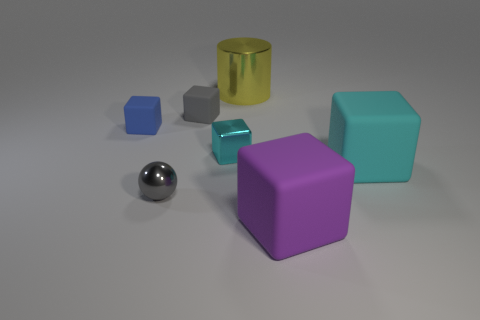How would you describe the arrangement of the objects in the image? The objects in the image are arranged diagonally across the scene, possibly to demonstrate contrast and comparison between their shapes, colors, and materials. What do the different materials of the objects suggest about their qualities? The smoothness of the metallic sphere suggests it's hard and reflective, while the rubbery texture of the cubes indicates flexibility and possibly a softness to the touch. The variations in material could also imply different uses for each object, underlining functional diversity. 